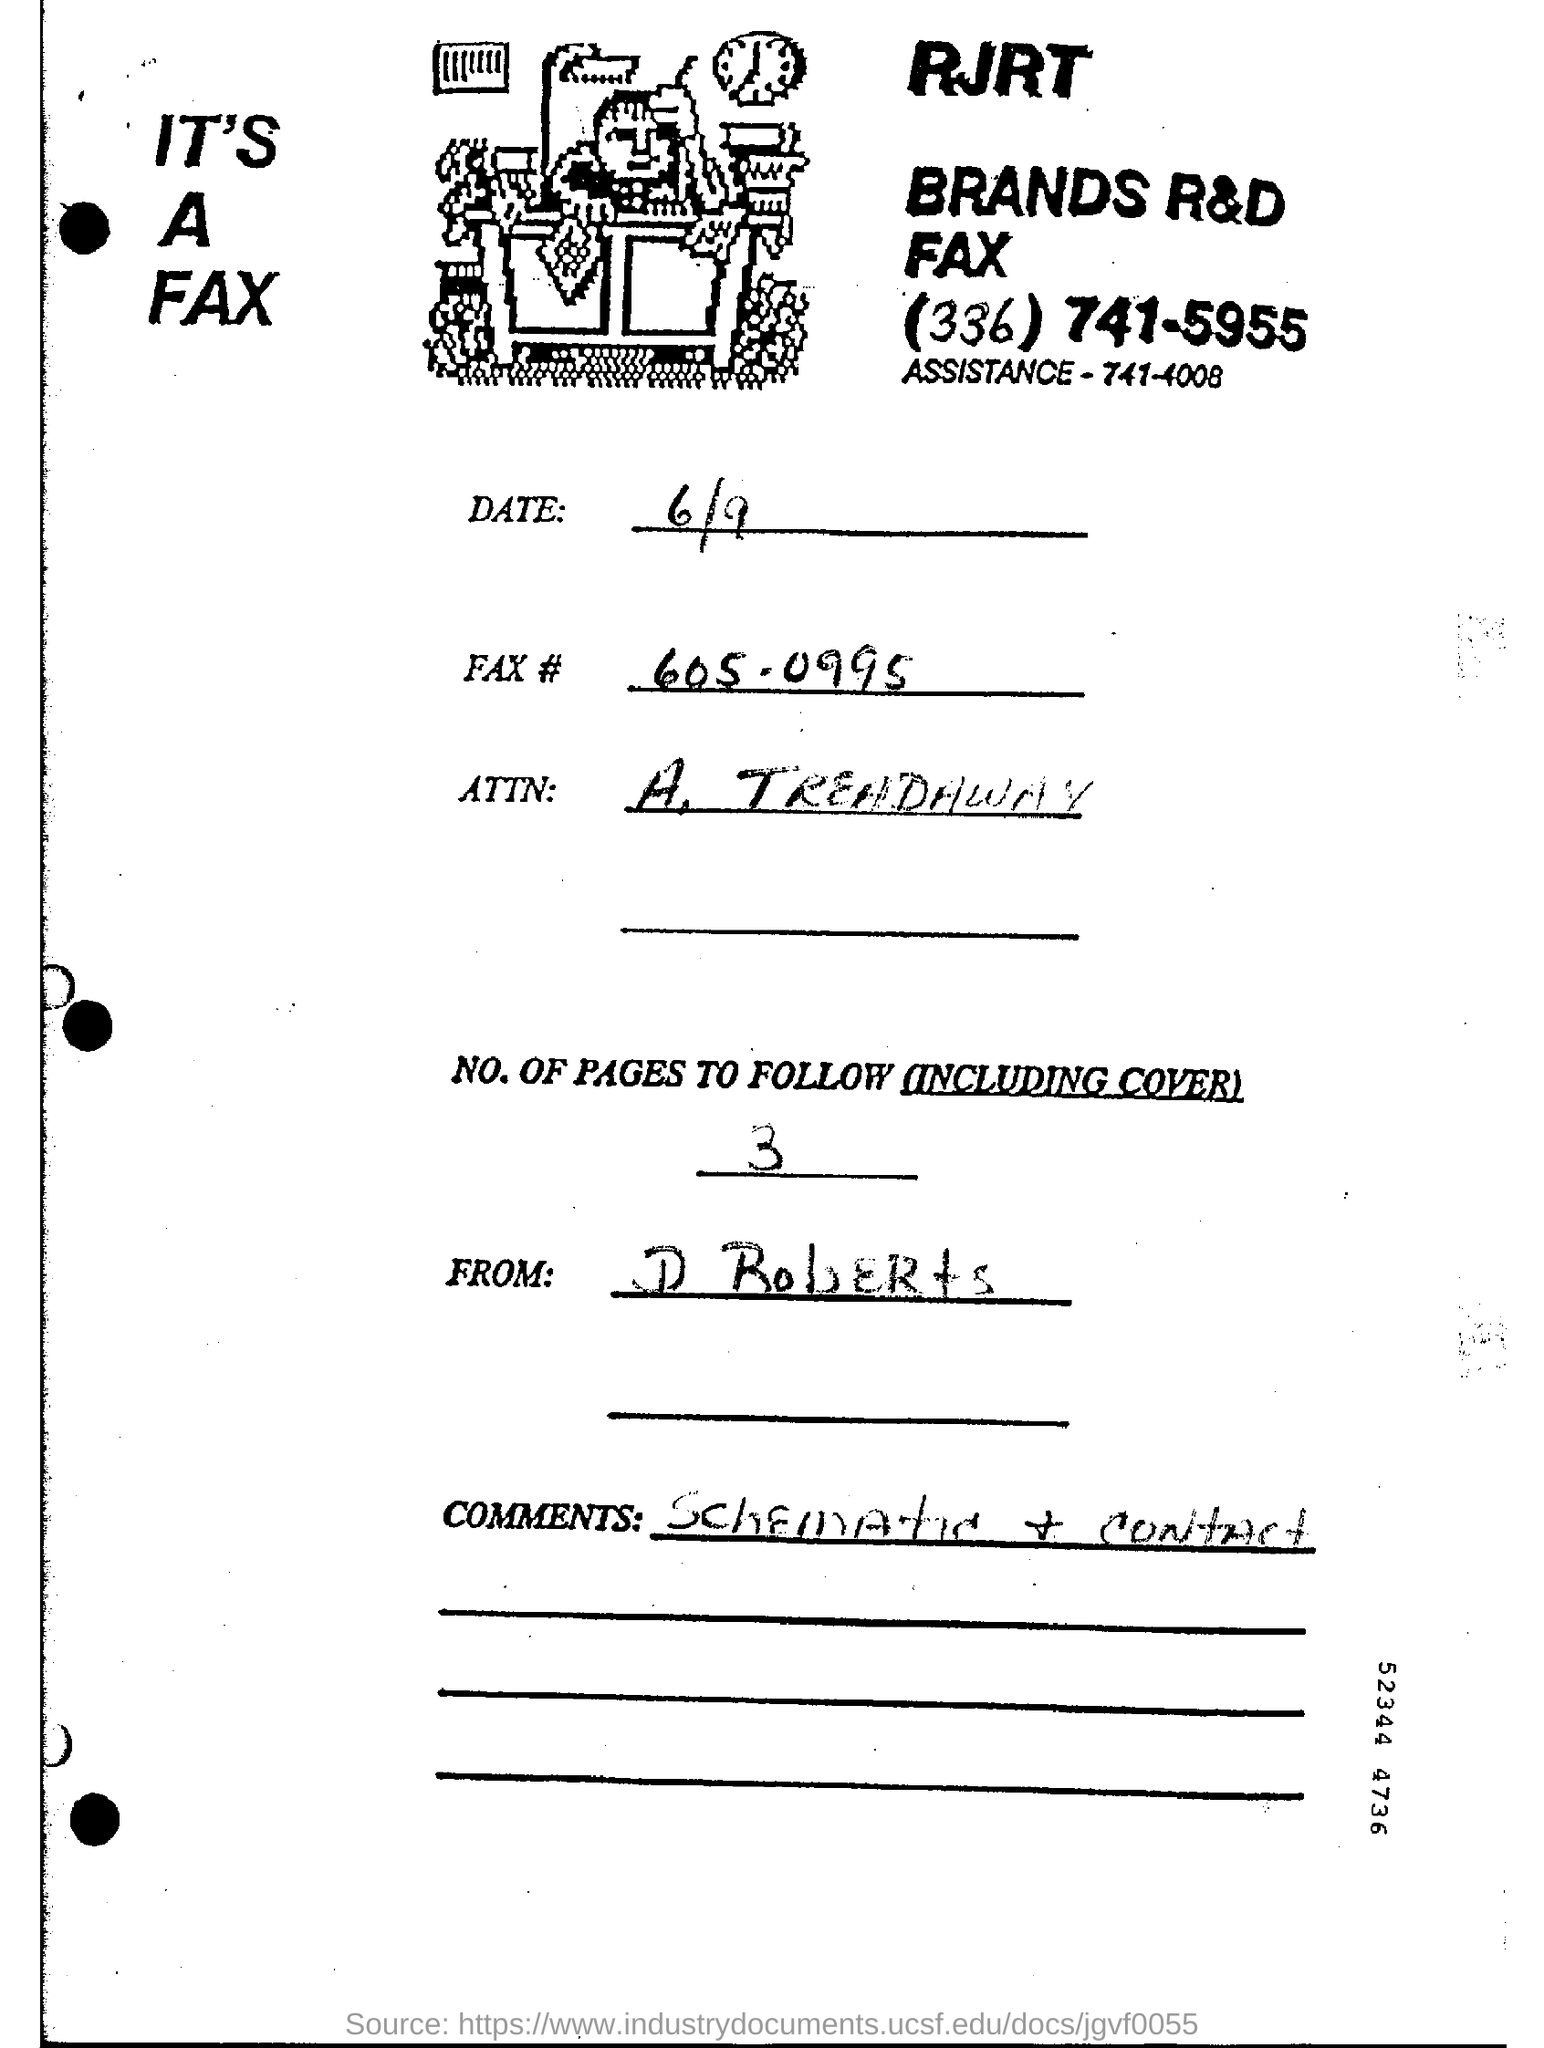What is the Date?
Provide a succinct answer. 6/9. What are the NO. of Pages to Follow (including cover)?
Offer a terse response. 3. What are the Comments?
Make the answer very short. Schematic & Contact. 